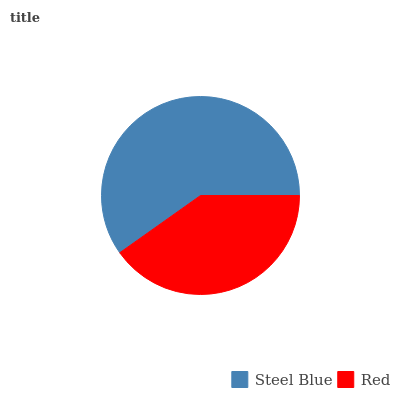Is Red the minimum?
Answer yes or no. Yes. Is Steel Blue the maximum?
Answer yes or no. Yes. Is Red the maximum?
Answer yes or no. No. Is Steel Blue greater than Red?
Answer yes or no. Yes. Is Red less than Steel Blue?
Answer yes or no. Yes. Is Red greater than Steel Blue?
Answer yes or no. No. Is Steel Blue less than Red?
Answer yes or no. No. Is Steel Blue the high median?
Answer yes or no. Yes. Is Red the low median?
Answer yes or no. Yes. Is Red the high median?
Answer yes or no. No. Is Steel Blue the low median?
Answer yes or no. No. 